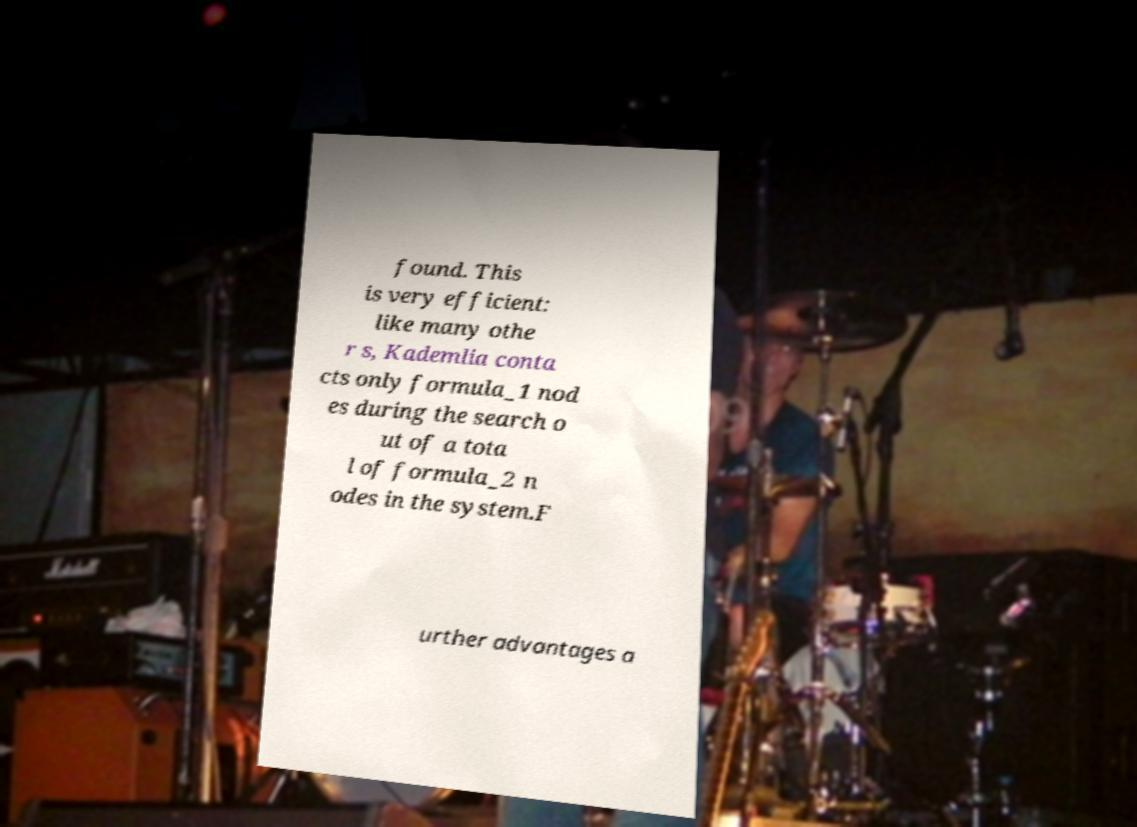There's text embedded in this image that I need extracted. Can you transcribe it verbatim? found. This is very efficient: like many othe r s, Kademlia conta cts only formula_1 nod es during the search o ut of a tota l of formula_2 n odes in the system.F urther advantages a 